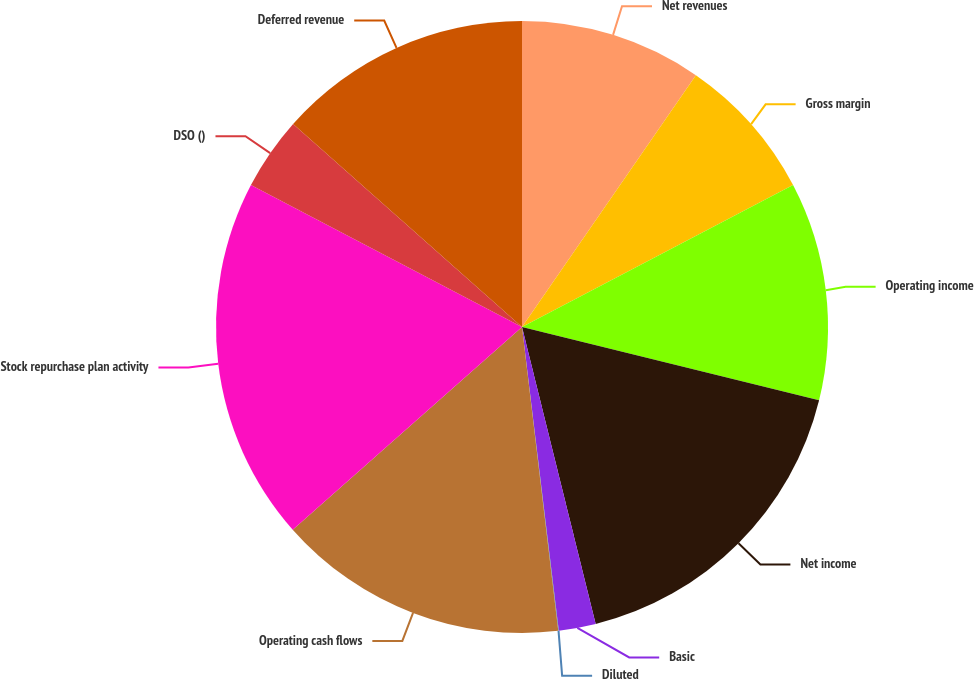Convert chart. <chart><loc_0><loc_0><loc_500><loc_500><pie_chart><fcel>Net revenues<fcel>Gross margin<fcel>Operating income<fcel>Net income<fcel>Basic<fcel>Diluted<fcel>Operating cash flows<fcel>Stock repurchase plan activity<fcel>DSO ()<fcel>Deferred revenue<nl><fcel>9.62%<fcel>7.7%<fcel>11.53%<fcel>17.28%<fcel>1.95%<fcel>0.03%<fcel>15.37%<fcel>19.2%<fcel>3.87%<fcel>13.45%<nl></chart> 